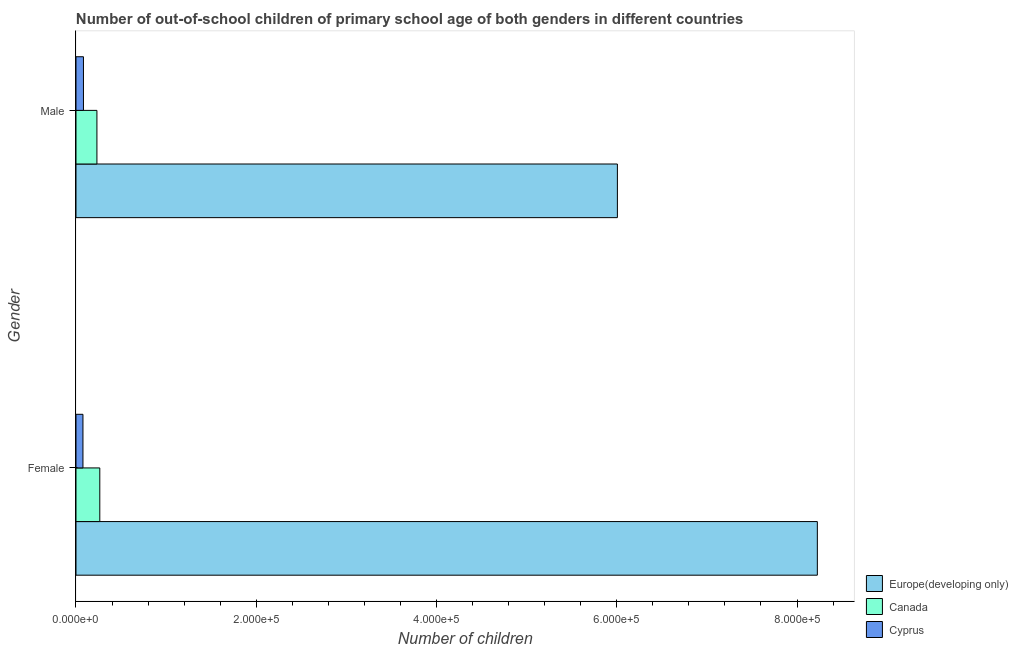How many different coloured bars are there?
Provide a short and direct response. 3. How many groups of bars are there?
Ensure brevity in your answer.  2. How many bars are there on the 1st tick from the top?
Give a very brief answer. 3. What is the label of the 2nd group of bars from the top?
Keep it short and to the point. Female. What is the number of female out-of-school students in Cyprus?
Your response must be concise. 7733. Across all countries, what is the maximum number of male out-of-school students?
Offer a terse response. 6.01e+05. Across all countries, what is the minimum number of male out-of-school students?
Keep it short and to the point. 8279. In which country was the number of female out-of-school students maximum?
Your answer should be very brief. Europe(developing only). In which country was the number of male out-of-school students minimum?
Give a very brief answer. Cyprus. What is the total number of female out-of-school students in the graph?
Keep it short and to the point. 8.57e+05. What is the difference between the number of male out-of-school students in Canada and that in Europe(developing only)?
Your response must be concise. -5.77e+05. What is the difference between the number of female out-of-school students in Canada and the number of male out-of-school students in Europe(developing only)?
Offer a terse response. -5.74e+05. What is the average number of male out-of-school students per country?
Your answer should be compact. 2.11e+05. What is the difference between the number of female out-of-school students and number of male out-of-school students in Canada?
Your answer should be very brief. 3186. In how many countries, is the number of female out-of-school students greater than 800000 ?
Your answer should be very brief. 1. What is the ratio of the number of male out-of-school students in Canada to that in Europe(developing only)?
Your answer should be very brief. 0.04. In how many countries, is the number of male out-of-school students greater than the average number of male out-of-school students taken over all countries?
Give a very brief answer. 1. What does the 3rd bar from the top in Female represents?
Make the answer very short. Europe(developing only). Are all the bars in the graph horizontal?
Offer a terse response. Yes. How many countries are there in the graph?
Your response must be concise. 3. Does the graph contain grids?
Offer a terse response. No. How many legend labels are there?
Your answer should be very brief. 3. How are the legend labels stacked?
Make the answer very short. Vertical. What is the title of the graph?
Provide a short and direct response. Number of out-of-school children of primary school age of both genders in different countries. Does "Peru" appear as one of the legend labels in the graph?
Provide a succinct answer. No. What is the label or title of the X-axis?
Give a very brief answer. Number of children. What is the Number of children of Europe(developing only) in Female?
Make the answer very short. 8.23e+05. What is the Number of children in Canada in Female?
Your answer should be compact. 2.64e+04. What is the Number of children of Cyprus in Female?
Offer a terse response. 7733. What is the Number of children in Europe(developing only) in Male?
Make the answer very short. 6.01e+05. What is the Number of children of Canada in Male?
Your answer should be very brief. 2.32e+04. What is the Number of children of Cyprus in Male?
Keep it short and to the point. 8279. Across all Gender, what is the maximum Number of children of Europe(developing only)?
Your answer should be compact. 8.23e+05. Across all Gender, what is the maximum Number of children of Canada?
Your answer should be very brief. 2.64e+04. Across all Gender, what is the maximum Number of children of Cyprus?
Keep it short and to the point. 8279. Across all Gender, what is the minimum Number of children of Europe(developing only)?
Give a very brief answer. 6.01e+05. Across all Gender, what is the minimum Number of children of Canada?
Keep it short and to the point. 2.32e+04. Across all Gender, what is the minimum Number of children of Cyprus?
Your response must be concise. 7733. What is the total Number of children in Europe(developing only) in the graph?
Your answer should be very brief. 1.42e+06. What is the total Number of children of Canada in the graph?
Your answer should be very brief. 4.96e+04. What is the total Number of children in Cyprus in the graph?
Give a very brief answer. 1.60e+04. What is the difference between the Number of children of Europe(developing only) in Female and that in Male?
Ensure brevity in your answer.  2.22e+05. What is the difference between the Number of children in Canada in Female and that in Male?
Make the answer very short. 3186. What is the difference between the Number of children in Cyprus in Female and that in Male?
Provide a succinct answer. -546. What is the difference between the Number of children of Europe(developing only) in Female and the Number of children of Canada in Male?
Offer a terse response. 7.99e+05. What is the difference between the Number of children of Europe(developing only) in Female and the Number of children of Cyprus in Male?
Your response must be concise. 8.14e+05. What is the difference between the Number of children of Canada in Female and the Number of children of Cyprus in Male?
Ensure brevity in your answer.  1.81e+04. What is the average Number of children in Europe(developing only) per Gender?
Offer a terse response. 7.12e+05. What is the average Number of children in Canada per Gender?
Give a very brief answer. 2.48e+04. What is the average Number of children in Cyprus per Gender?
Offer a terse response. 8006. What is the difference between the Number of children of Europe(developing only) and Number of children of Canada in Female?
Your response must be concise. 7.96e+05. What is the difference between the Number of children in Europe(developing only) and Number of children in Cyprus in Female?
Provide a short and direct response. 8.15e+05. What is the difference between the Number of children in Canada and Number of children in Cyprus in Female?
Provide a succinct answer. 1.87e+04. What is the difference between the Number of children in Europe(developing only) and Number of children in Canada in Male?
Give a very brief answer. 5.77e+05. What is the difference between the Number of children in Europe(developing only) and Number of children in Cyprus in Male?
Offer a very short reply. 5.92e+05. What is the difference between the Number of children in Canada and Number of children in Cyprus in Male?
Provide a short and direct response. 1.49e+04. What is the ratio of the Number of children in Europe(developing only) in Female to that in Male?
Provide a short and direct response. 1.37. What is the ratio of the Number of children of Canada in Female to that in Male?
Keep it short and to the point. 1.14. What is the ratio of the Number of children of Cyprus in Female to that in Male?
Ensure brevity in your answer.  0.93. What is the difference between the highest and the second highest Number of children in Europe(developing only)?
Your answer should be very brief. 2.22e+05. What is the difference between the highest and the second highest Number of children of Canada?
Your response must be concise. 3186. What is the difference between the highest and the second highest Number of children of Cyprus?
Provide a short and direct response. 546. What is the difference between the highest and the lowest Number of children in Europe(developing only)?
Offer a very short reply. 2.22e+05. What is the difference between the highest and the lowest Number of children of Canada?
Give a very brief answer. 3186. What is the difference between the highest and the lowest Number of children of Cyprus?
Your answer should be compact. 546. 